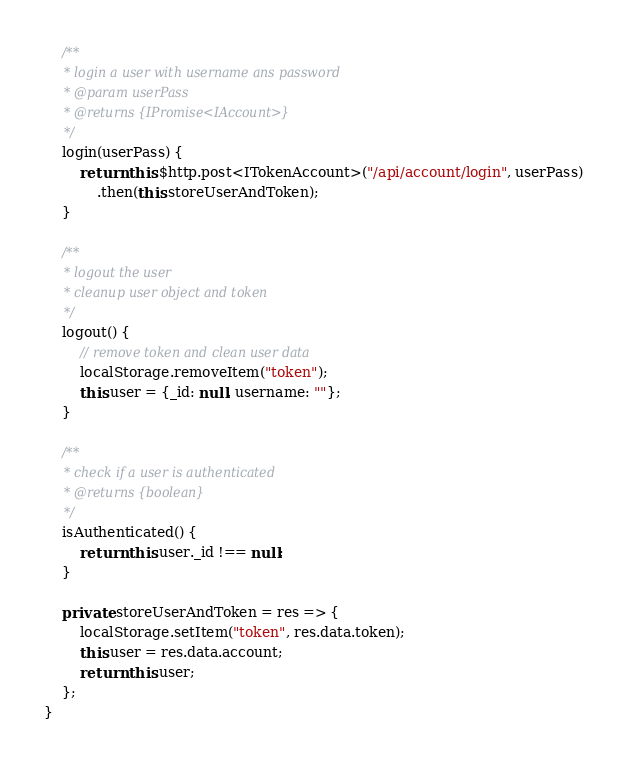Convert code to text. <code><loc_0><loc_0><loc_500><loc_500><_TypeScript_>
    /**
     * login a user with username ans password
     * @param userPass
     * @returns {IPromise<IAccount>}
     */
    login(userPass) {
        return this.$http.post<ITokenAccount>("/api/account/login", userPass)
            .then(this.storeUserAndToken);
    }

    /**
     * logout the user
     * cleanup user object and token
     */
    logout() {
        // remove token and clean user data
        localStorage.removeItem("token");
        this.user = {_id: null, username: ""};
    }

    /**
     * check if a user is authenticated
     * @returns {boolean}
     */
    isAuthenticated() {
        return this.user._id !== null;
    }

    private storeUserAndToken = res => {
        localStorage.setItem("token", res.data.token);
        this.user = res.data.account;
        return this.user;
    };
}
</code> 